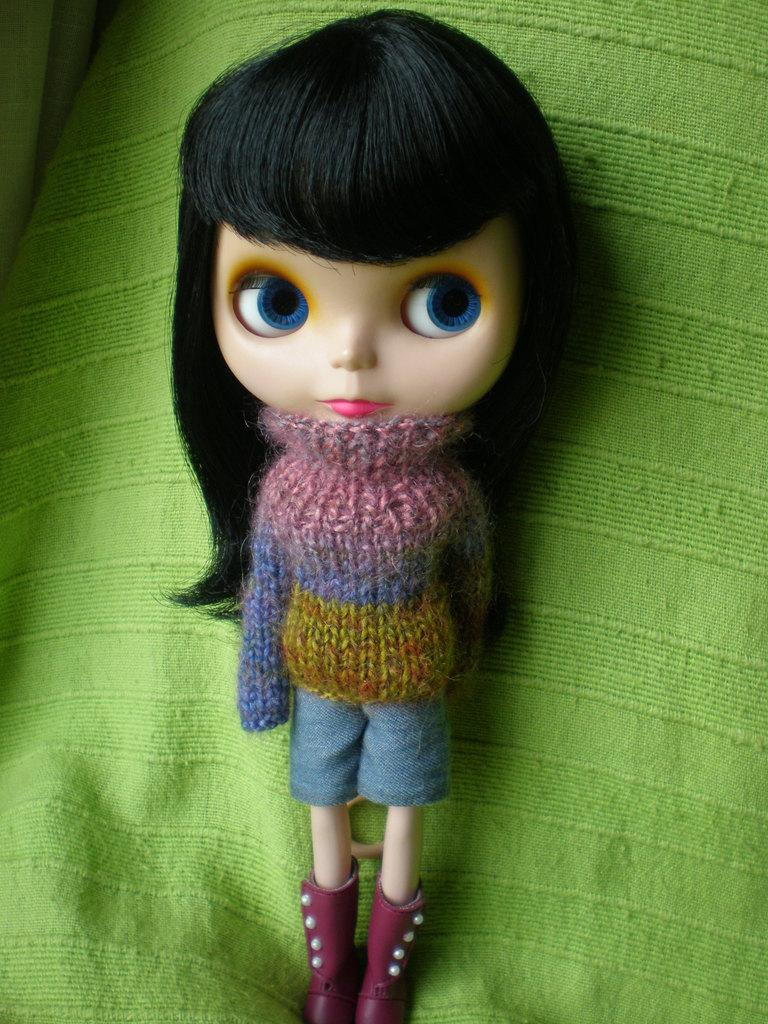What object can be seen in the image? There is a toy in the image. What is the toy wearing? The toy is wearing a colorful dress. What color is the background of the image? The background of the image is green. How many pigs are sitting on the toy's head in the image? There are no pigs present in the image, and therefore none are sitting on the toy's head. Is the queen of England holding the toy in the image? There is no reference to the queen of England or any person holding the toy in the image. 